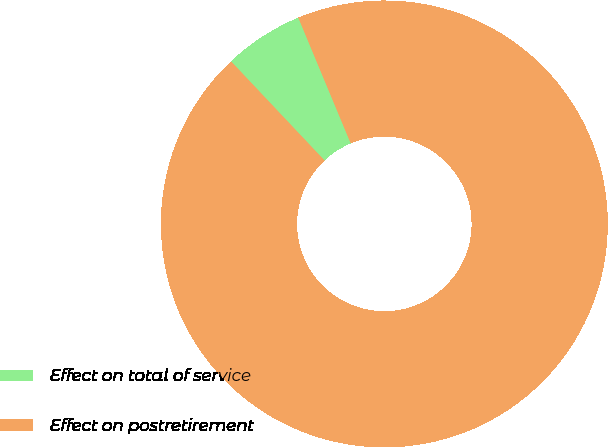Convert chart. <chart><loc_0><loc_0><loc_500><loc_500><pie_chart><fcel>Effect on total of service<fcel>Effect on postretirement<nl><fcel>5.75%<fcel>94.25%<nl></chart> 